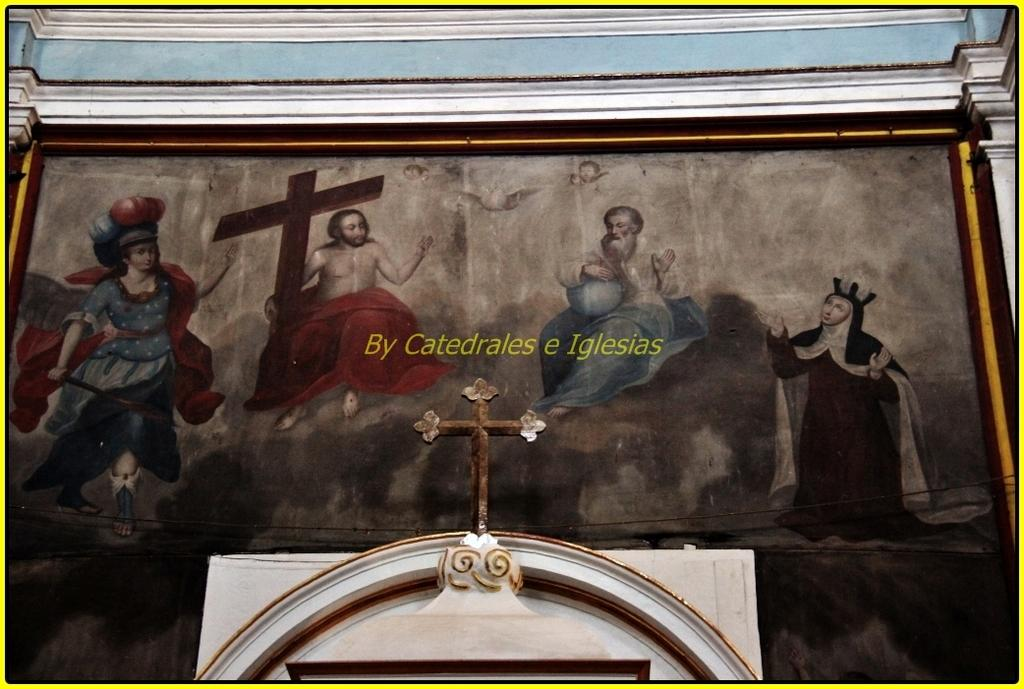What symbols can be seen in the image? There are crosses in the image. What type of structure is visible in the image? There is a wall in the image. Who or what is present in the image? There are people in the image. Can you describe any other objects in the image? There are unspecified objects in the image. What type of marble is being used to create the protest signs in the image? There is no mention of protest signs or marble in the image; it features crosses, a wall, people, and unspecified objects. 